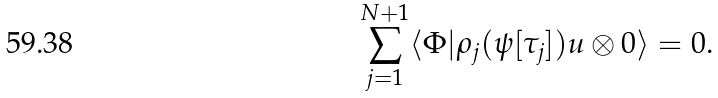Convert formula to latex. <formula><loc_0><loc_0><loc_500><loc_500>\sum _ { j = 1 } ^ { N + 1 } \langle \Phi | \rho _ { j } ( \psi [ \tau _ { j } ] ) u \otimes 0 \rangle = 0 .</formula> 